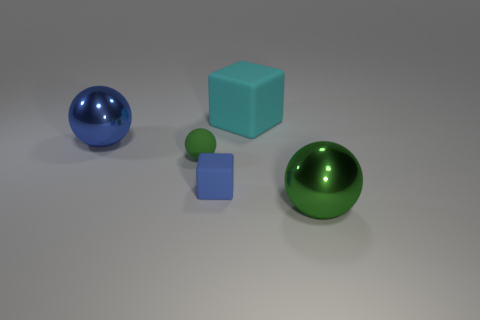How many tiny things are either cubes or purple cubes? In the image, there are two objects that can be classified as tiny things that are either cubes or purple cubes. One of them is a tiny cube that's light blue and another is a tiny cube that is purple. 